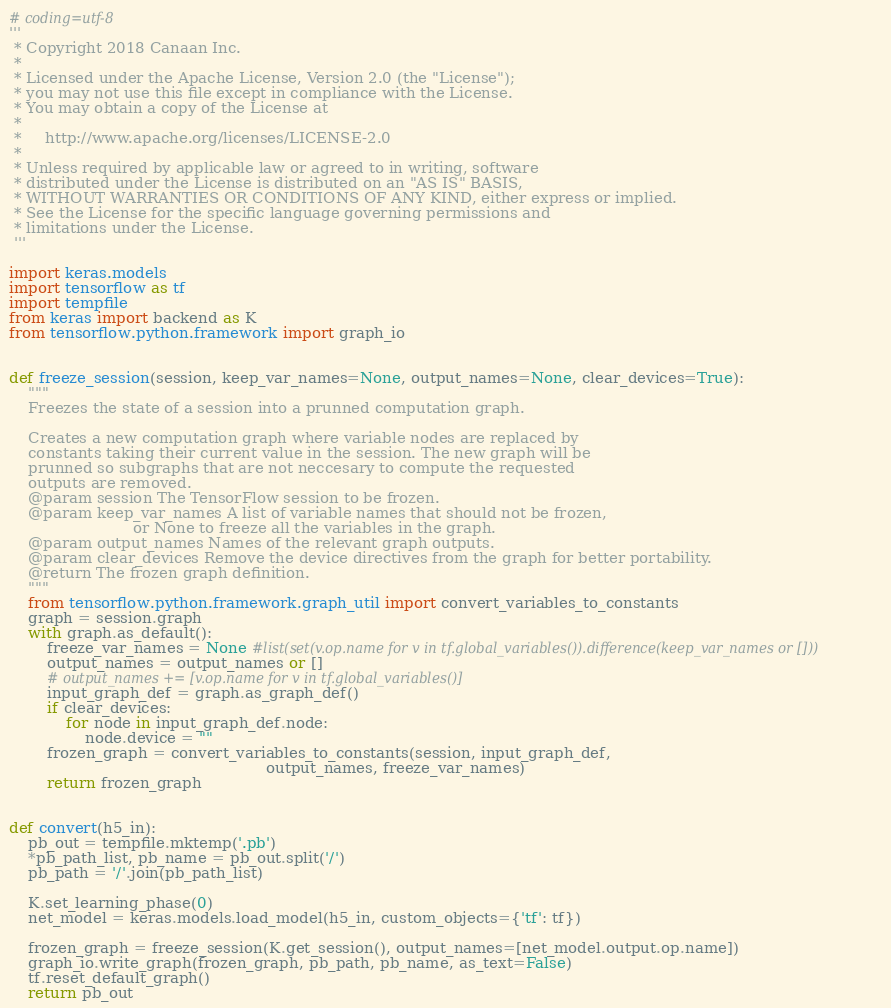<code> <loc_0><loc_0><loc_500><loc_500><_Python_># coding=utf-8
'''
 * Copyright 2018 Canaan Inc.
 *
 * Licensed under the Apache License, Version 2.0 (the "License");
 * you may not use this file except in compliance with the License.
 * You may obtain a copy of the License at
 *
 *     http://www.apache.org/licenses/LICENSE-2.0
 *
 * Unless required by applicable law or agreed to in writing, software
 * distributed under the License is distributed on an "AS IS" BASIS,
 * WITHOUT WARRANTIES OR CONDITIONS OF ANY KIND, either express or implied.
 * See the License for the specific language governing permissions and
 * limitations under the License.
 '''
 
import keras.models
import tensorflow as tf
import tempfile
from keras import backend as K
from tensorflow.python.framework import graph_io


def freeze_session(session, keep_var_names=None, output_names=None, clear_devices=True):
    """
    Freezes the state of a session into a prunned computation graph.

    Creates a new computation graph where variable nodes are replaced by
    constants taking their current value in the session. The new graph will be
    prunned so subgraphs that are not neccesary to compute the requested
    outputs are removed.
    @param session The TensorFlow session to be frozen.
    @param keep_var_names A list of variable names that should not be frozen,
                          or None to freeze all the variables in the graph.
    @param output_names Names of the relevant graph outputs.
    @param clear_devices Remove the device directives from the graph for better portability.
    @return The frozen graph definition.
    """
    from tensorflow.python.framework.graph_util import convert_variables_to_constants
    graph = session.graph
    with graph.as_default():
        freeze_var_names = None #list(set(v.op.name for v in tf.global_variables()).difference(keep_var_names or []))
        output_names = output_names or []
        # output_names += [v.op.name for v in tf.global_variables()]
        input_graph_def = graph.as_graph_def()
        if clear_devices:
            for node in input_graph_def.node:
                node.device = ""
        frozen_graph = convert_variables_to_constants(session, input_graph_def,
                                                      output_names, freeze_var_names)
        return frozen_graph


def convert(h5_in):
    pb_out = tempfile.mktemp('.pb')
    *pb_path_list, pb_name = pb_out.split('/')
    pb_path = '/'.join(pb_path_list)

    K.set_learning_phase(0)
    net_model = keras.models.load_model(h5_in, custom_objects={'tf': tf})

    frozen_graph = freeze_session(K.get_session(), output_names=[net_model.output.op.name])
    graph_io.write_graph(frozen_graph, pb_path, pb_name, as_text=False)
    tf.reset_default_graph()
    return pb_out
</code> 